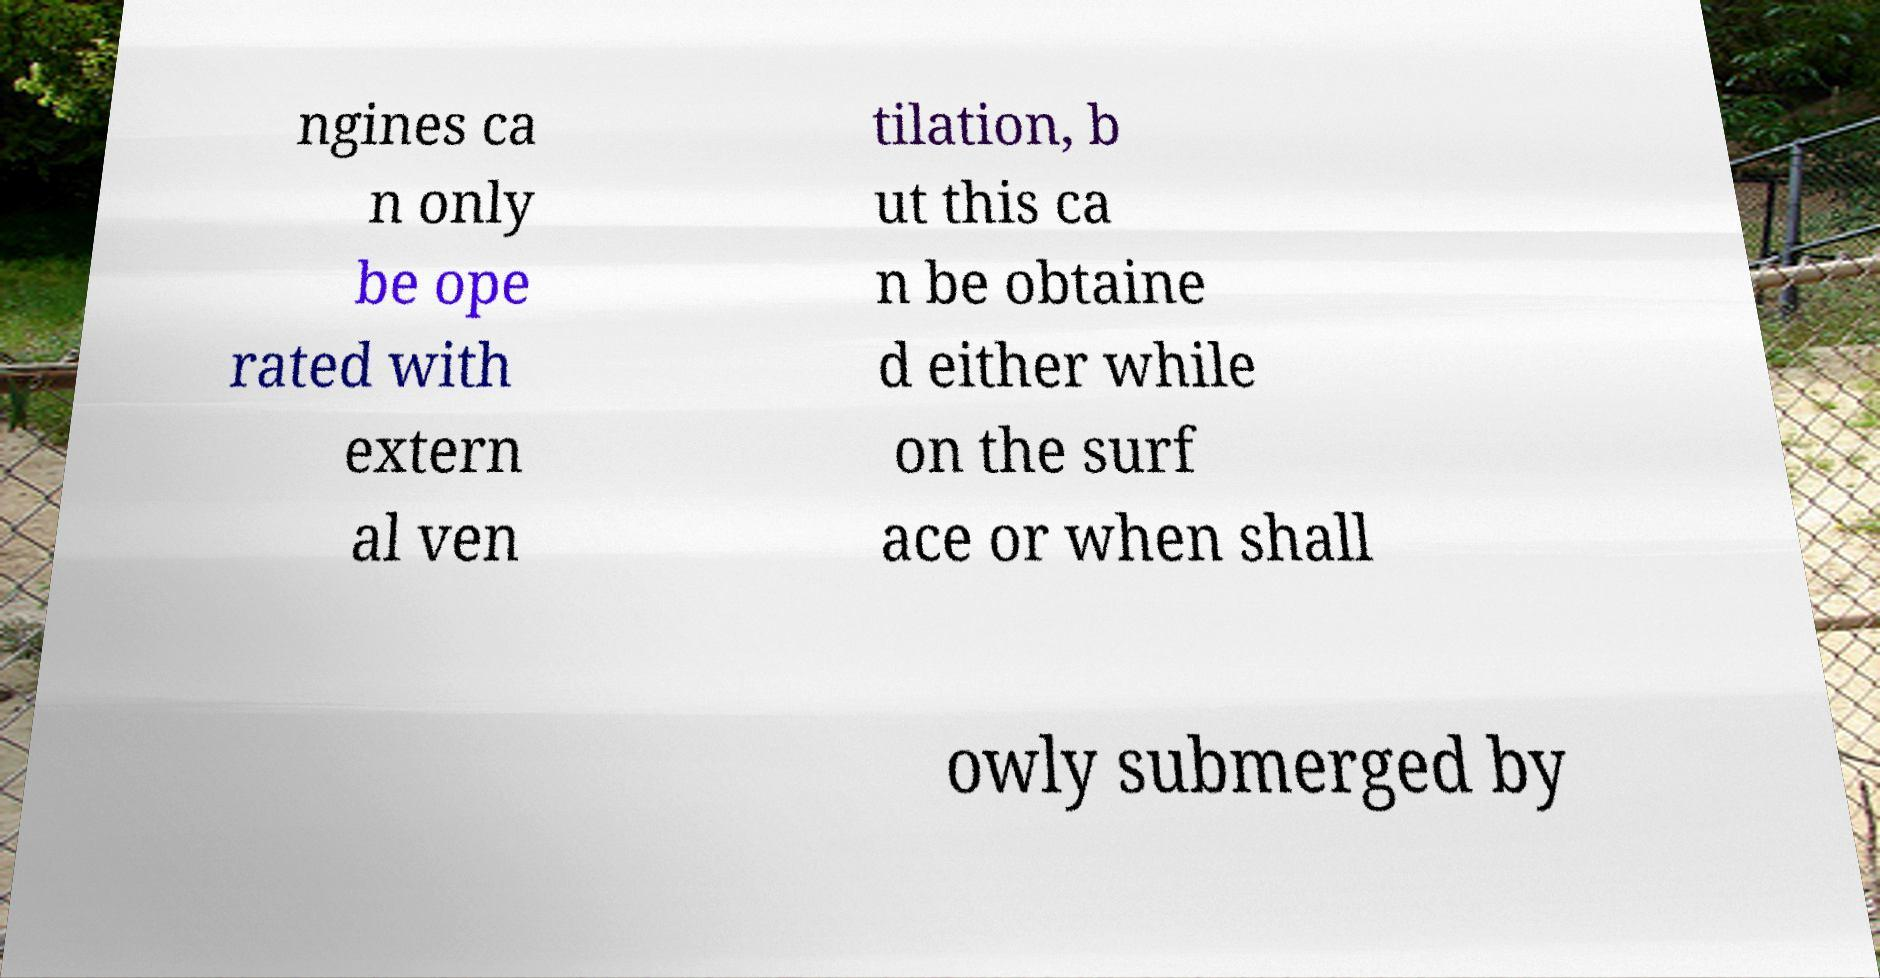Can you accurately transcribe the text from the provided image for me? ngines ca n only be ope rated with extern al ven tilation, b ut this ca n be obtaine d either while on the surf ace or when shall owly submerged by 